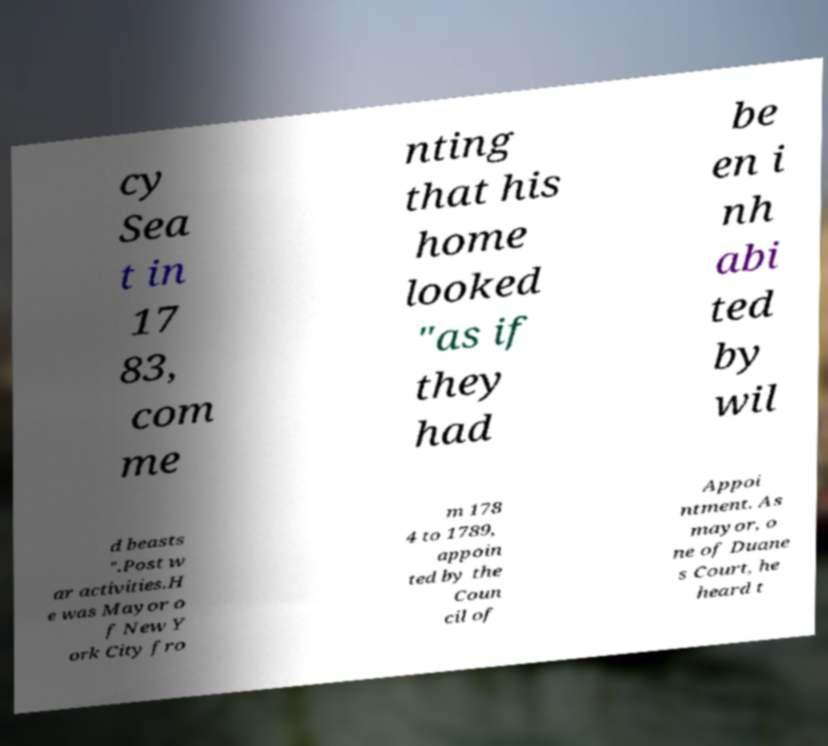Please read and relay the text visible in this image. What does it say? cy Sea t in 17 83, com me nting that his home looked "as if they had be en i nh abi ted by wil d beasts ".Post w ar activities.H e was Mayor o f New Y ork City fro m 178 4 to 1789, appoin ted by the Coun cil of Appoi ntment. As mayor, o ne of Duane s Court, he heard t 